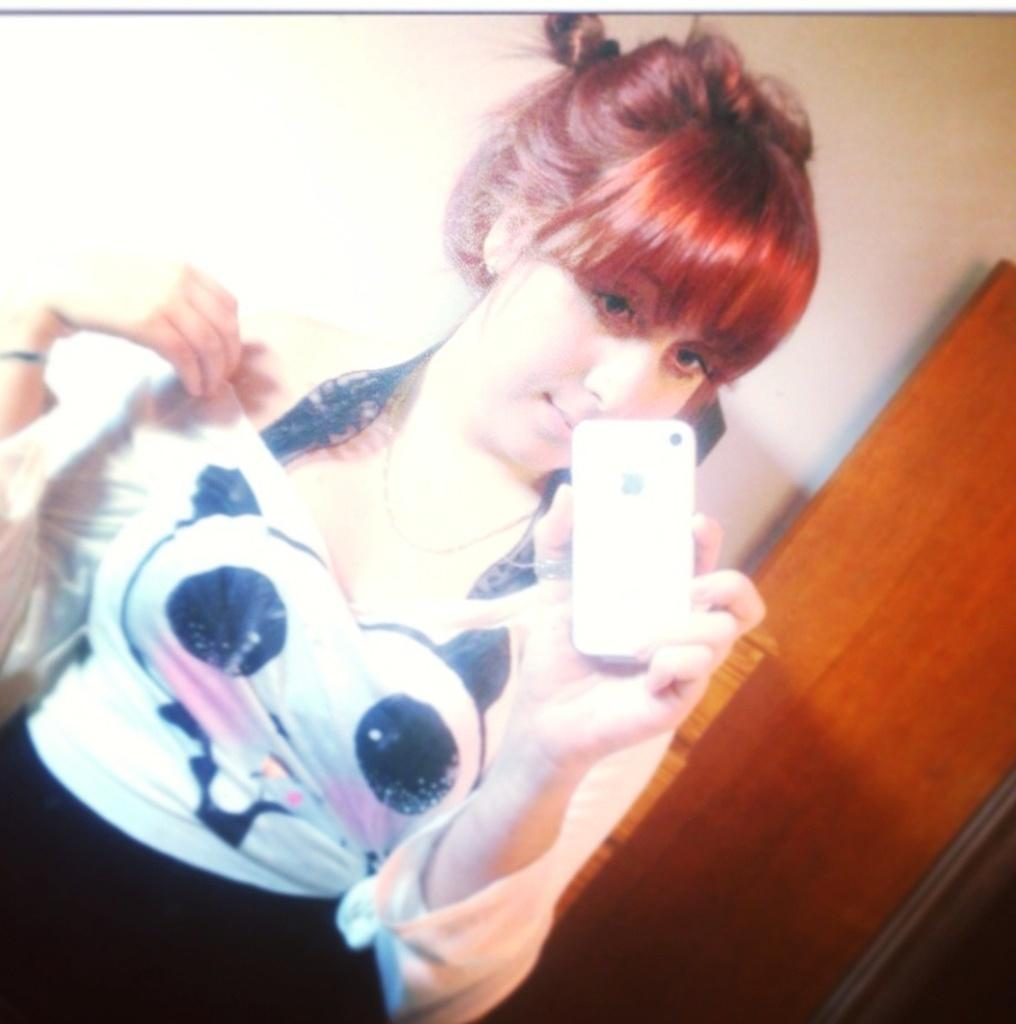Who or what is in the image? There is a person in the image. What is behind the person in the image? The person is in front of a wall. What is the person holding in her hand? The person is holding a phone in her hand. What type of punishment is being administered to the person in the image? There is no indication of punishment in the image; the person is simply standing in front of a wall and holding a phone. 